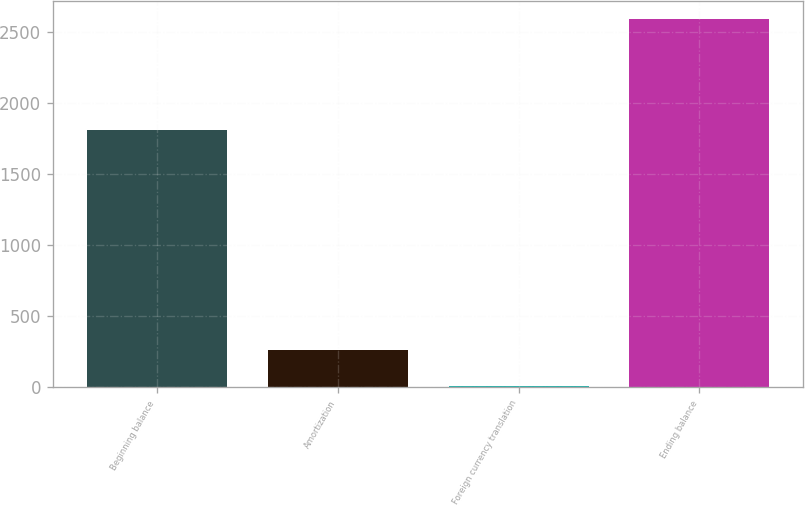<chart> <loc_0><loc_0><loc_500><loc_500><bar_chart><fcel>Beginning balance<fcel>Amortization<fcel>Foreign currency translation<fcel>Ending balance<nl><fcel>1810<fcel>265.6<fcel>7<fcel>2593<nl></chart> 